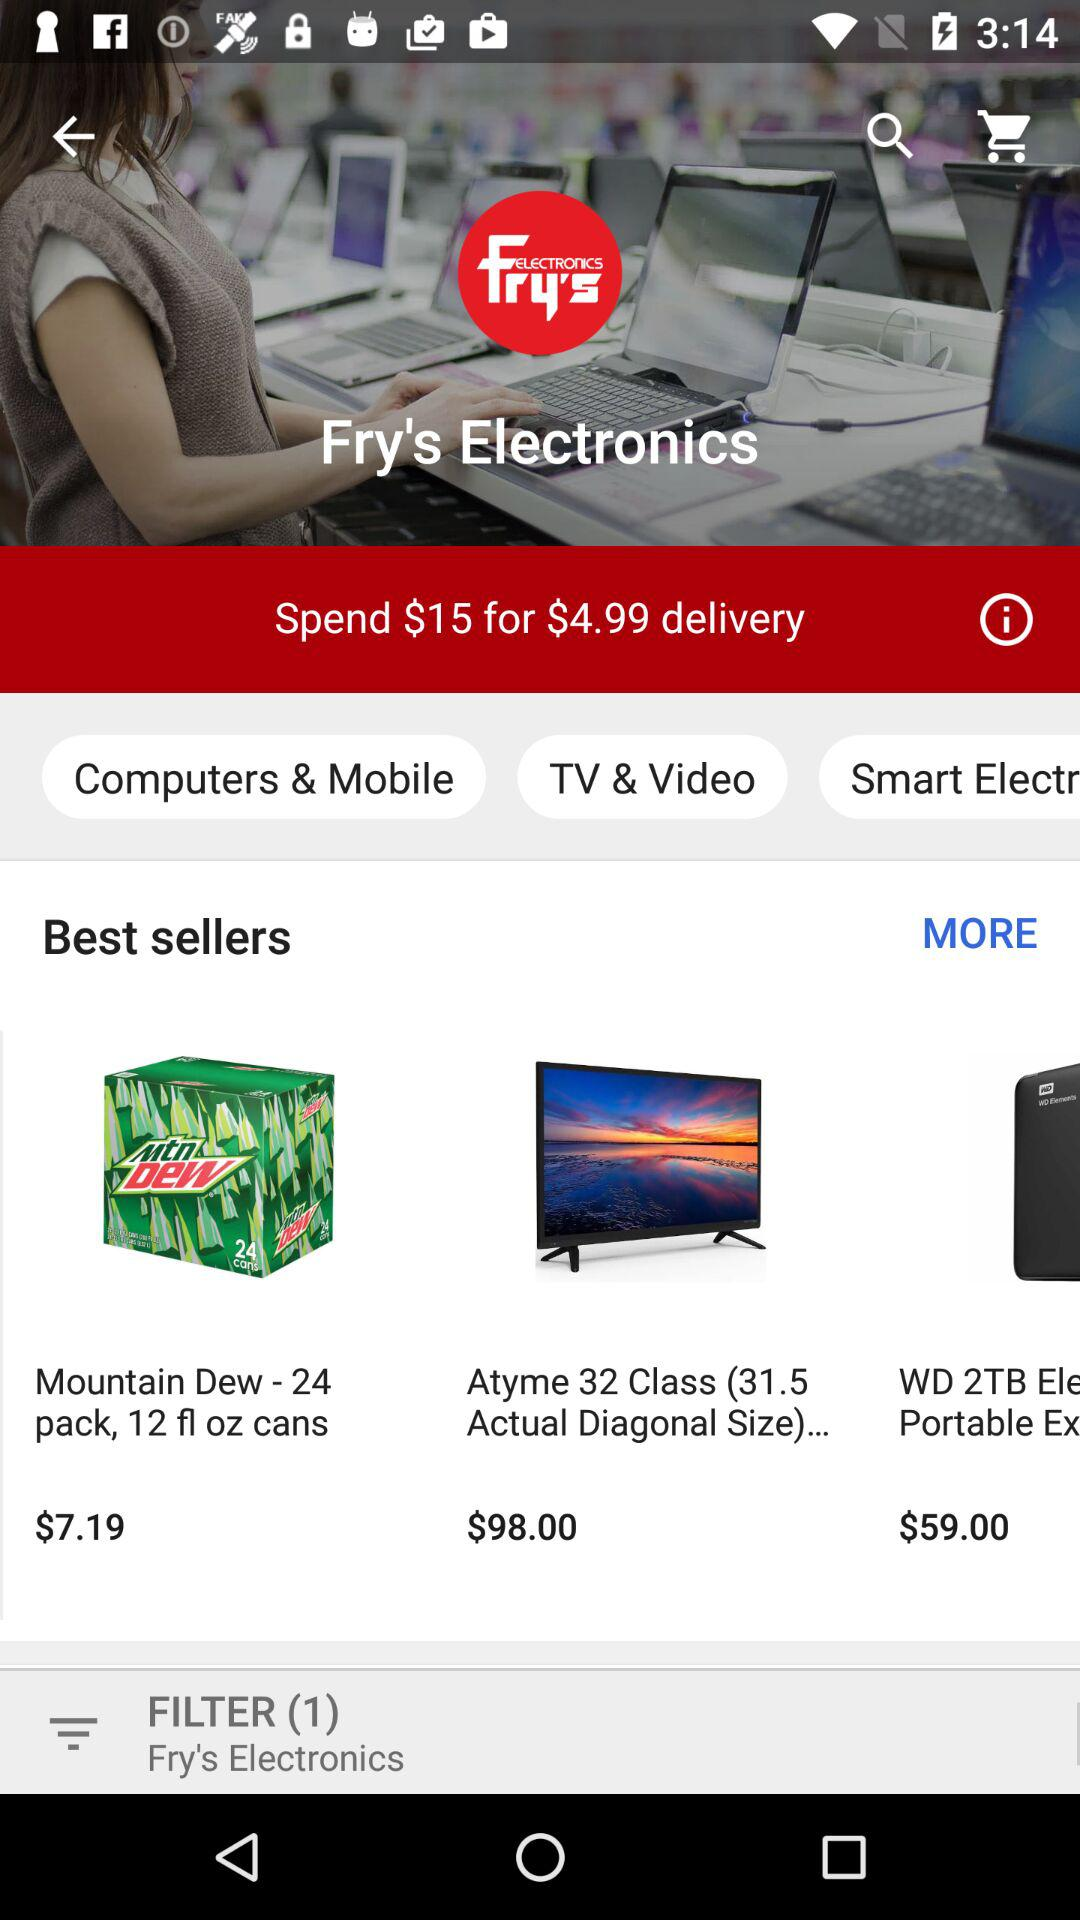What is the price of "Mountain Dew - 24 pack, 12 fl oz cans"? The price of "Mountain Dew - 24 pack, 12 fl oz cans" is $7.19. 